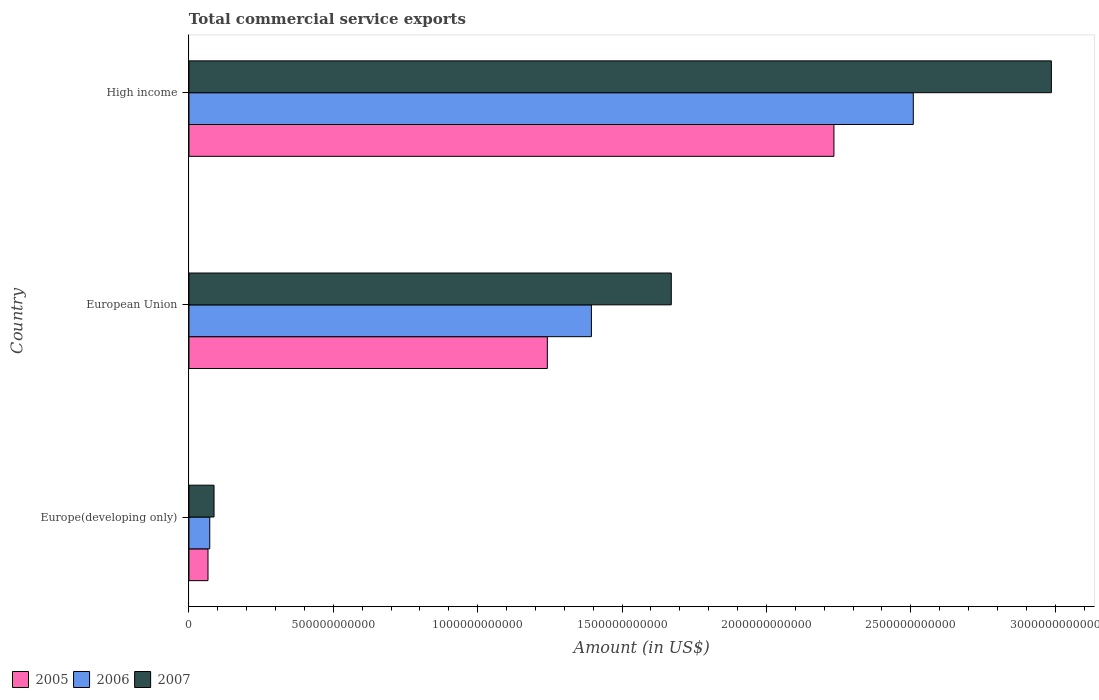How many groups of bars are there?
Provide a succinct answer. 3. Are the number of bars on each tick of the Y-axis equal?
Make the answer very short. Yes. What is the label of the 3rd group of bars from the top?
Your answer should be compact. Europe(developing only). What is the total commercial service exports in 2005 in High income?
Give a very brief answer. 2.23e+12. Across all countries, what is the maximum total commercial service exports in 2006?
Provide a short and direct response. 2.51e+12. Across all countries, what is the minimum total commercial service exports in 2007?
Offer a very short reply. 8.67e+1. In which country was the total commercial service exports in 2007 minimum?
Make the answer very short. Europe(developing only). What is the total total commercial service exports in 2005 in the graph?
Provide a short and direct response. 3.54e+12. What is the difference between the total commercial service exports in 2007 in Europe(developing only) and that in European Union?
Give a very brief answer. -1.58e+12. What is the difference between the total commercial service exports in 2005 in Europe(developing only) and the total commercial service exports in 2007 in High income?
Your response must be concise. -2.92e+12. What is the average total commercial service exports in 2007 per country?
Provide a succinct answer. 1.58e+12. What is the difference between the total commercial service exports in 2007 and total commercial service exports in 2006 in Europe(developing only)?
Keep it short and to the point. 1.48e+1. In how many countries, is the total commercial service exports in 2006 greater than 2000000000000 US$?
Ensure brevity in your answer.  1. What is the ratio of the total commercial service exports in 2006 in European Union to that in High income?
Provide a succinct answer. 0.56. What is the difference between the highest and the second highest total commercial service exports in 2006?
Your response must be concise. 1.11e+12. What is the difference between the highest and the lowest total commercial service exports in 2005?
Your response must be concise. 2.17e+12. In how many countries, is the total commercial service exports in 2005 greater than the average total commercial service exports in 2005 taken over all countries?
Your answer should be compact. 2. Is the sum of the total commercial service exports in 2005 in Europe(developing only) and European Union greater than the maximum total commercial service exports in 2007 across all countries?
Provide a short and direct response. No. What does the 3rd bar from the bottom in European Union represents?
Keep it short and to the point. 2007. Is it the case that in every country, the sum of the total commercial service exports in 2007 and total commercial service exports in 2005 is greater than the total commercial service exports in 2006?
Ensure brevity in your answer.  Yes. Are all the bars in the graph horizontal?
Provide a short and direct response. Yes. How many countries are there in the graph?
Make the answer very short. 3. What is the difference between two consecutive major ticks on the X-axis?
Your response must be concise. 5.00e+11. Are the values on the major ticks of X-axis written in scientific E-notation?
Your answer should be very brief. No. Does the graph contain grids?
Give a very brief answer. No. Where does the legend appear in the graph?
Your answer should be very brief. Bottom left. How many legend labels are there?
Ensure brevity in your answer.  3. What is the title of the graph?
Offer a very short reply. Total commercial service exports. What is the label or title of the X-axis?
Provide a short and direct response. Amount (in US$). What is the Amount (in US$) in 2005 in Europe(developing only)?
Your response must be concise. 6.59e+1. What is the Amount (in US$) in 2006 in Europe(developing only)?
Provide a short and direct response. 7.19e+1. What is the Amount (in US$) of 2007 in Europe(developing only)?
Offer a very short reply. 8.67e+1. What is the Amount (in US$) in 2005 in European Union?
Ensure brevity in your answer.  1.24e+12. What is the Amount (in US$) of 2006 in European Union?
Provide a succinct answer. 1.39e+12. What is the Amount (in US$) in 2007 in European Union?
Keep it short and to the point. 1.67e+12. What is the Amount (in US$) in 2005 in High income?
Ensure brevity in your answer.  2.23e+12. What is the Amount (in US$) in 2006 in High income?
Give a very brief answer. 2.51e+12. What is the Amount (in US$) in 2007 in High income?
Ensure brevity in your answer.  2.99e+12. Across all countries, what is the maximum Amount (in US$) in 2005?
Ensure brevity in your answer.  2.23e+12. Across all countries, what is the maximum Amount (in US$) of 2006?
Make the answer very short. 2.51e+12. Across all countries, what is the maximum Amount (in US$) in 2007?
Give a very brief answer. 2.99e+12. Across all countries, what is the minimum Amount (in US$) of 2005?
Provide a succinct answer. 6.59e+1. Across all countries, what is the minimum Amount (in US$) in 2006?
Provide a succinct answer. 7.19e+1. Across all countries, what is the minimum Amount (in US$) of 2007?
Provide a succinct answer. 8.67e+1. What is the total Amount (in US$) in 2005 in the graph?
Offer a very short reply. 3.54e+12. What is the total Amount (in US$) in 2006 in the graph?
Ensure brevity in your answer.  3.97e+12. What is the total Amount (in US$) of 2007 in the graph?
Your response must be concise. 4.74e+12. What is the difference between the Amount (in US$) in 2005 in Europe(developing only) and that in European Union?
Offer a very short reply. -1.18e+12. What is the difference between the Amount (in US$) in 2006 in Europe(developing only) and that in European Union?
Offer a terse response. -1.32e+12. What is the difference between the Amount (in US$) of 2007 in Europe(developing only) and that in European Union?
Give a very brief answer. -1.58e+12. What is the difference between the Amount (in US$) of 2005 in Europe(developing only) and that in High income?
Give a very brief answer. -2.17e+12. What is the difference between the Amount (in US$) of 2006 in Europe(developing only) and that in High income?
Give a very brief answer. -2.44e+12. What is the difference between the Amount (in US$) of 2007 in Europe(developing only) and that in High income?
Offer a terse response. -2.90e+12. What is the difference between the Amount (in US$) in 2005 in European Union and that in High income?
Make the answer very short. -9.93e+11. What is the difference between the Amount (in US$) of 2006 in European Union and that in High income?
Your answer should be very brief. -1.11e+12. What is the difference between the Amount (in US$) in 2007 in European Union and that in High income?
Provide a succinct answer. -1.32e+12. What is the difference between the Amount (in US$) of 2005 in Europe(developing only) and the Amount (in US$) of 2006 in European Union?
Your answer should be compact. -1.33e+12. What is the difference between the Amount (in US$) of 2005 in Europe(developing only) and the Amount (in US$) of 2007 in European Union?
Offer a terse response. -1.60e+12. What is the difference between the Amount (in US$) in 2006 in Europe(developing only) and the Amount (in US$) in 2007 in European Union?
Your answer should be compact. -1.60e+12. What is the difference between the Amount (in US$) in 2005 in Europe(developing only) and the Amount (in US$) in 2006 in High income?
Make the answer very short. -2.44e+12. What is the difference between the Amount (in US$) in 2005 in Europe(developing only) and the Amount (in US$) in 2007 in High income?
Offer a terse response. -2.92e+12. What is the difference between the Amount (in US$) in 2006 in Europe(developing only) and the Amount (in US$) in 2007 in High income?
Your answer should be very brief. -2.91e+12. What is the difference between the Amount (in US$) in 2005 in European Union and the Amount (in US$) in 2006 in High income?
Give a very brief answer. -1.27e+12. What is the difference between the Amount (in US$) of 2005 in European Union and the Amount (in US$) of 2007 in High income?
Your response must be concise. -1.75e+12. What is the difference between the Amount (in US$) in 2006 in European Union and the Amount (in US$) in 2007 in High income?
Offer a terse response. -1.59e+12. What is the average Amount (in US$) in 2005 per country?
Provide a short and direct response. 1.18e+12. What is the average Amount (in US$) of 2006 per country?
Your answer should be very brief. 1.32e+12. What is the average Amount (in US$) in 2007 per country?
Your answer should be very brief. 1.58e+12. What is the difference between the Amount (in US$) in 2005 and Amount (in US$) in 2006 in Europe(developing only)?
Make the answer very short. -6.08e+09. What is the difference between the Amount (in US$) in 2005 and Amount (in US$) in 2007 in Europe(developing only)?
Offer a terse response. -2.09e+1. What is the difference between the Amount (in US$) of 2006 and Amount (in US$) of 2007 in Europe(developing only)?
Provide a short and direct response. -1.48e+1. What is the difference between the Amount (in US$) of 2005 and Amount (in US$) of 2006 in European Union?
Your answer should be very brief. -1.53e+11. What is the difference between the Amount (in US$) of 2005 and Amount (in US$) of 2007 in European Union?
Provide a short and direct response. -4.29e+11. What is the difference between the Amount (in US$) in 2006 and Amount (in US$) in 2007 in European Union?
Offer a very short reply. -2.77e+11. What is the difference between the Amount (in US$) in 2005 and Amount (in US$) in 2006 in High income?
Provide a short and direct response. -2.75e+11. What is the difference between the Amount (in US$) of 2005 and Amount (in US$) of 2007 in High income?
Ensure brevity in your answer.  -7.53e+11. What is the difference between the Amount (in US$) in 2006 and Amount (in US$) in 2007 in High income?
Give a very brief answer. -4.78e+11. What is the ratio of the Amount (in US$) in 2005 in Europe(developing only) to that in European Union?
Offer a terse response. 0.05. What is the ratio of the Amount (in US$) of 2006 in Europe(developing only) to that in European Union?
Your answer should be compact. 0.05. What is the ratio of the Amount (in US$) of 2007 in Europe(developing only) to that in European Union?
Provide a succinct answer. 0.05. What is the ratio of the Amount (in US$) in 2005 in Europe(developing only) to that in High income?
Your answer should be very brief. 0.03. What is the ratio of the Amount (in US$) of 2006 in Europe(developing only) to that in High income?
Offer a terse response. 0.03. What is the ratio of the Amount (in US$) in 2007 in Europe(developing only) to that in High income?
Ensure brevity in your answer.  0.03. What is the ratio of the Amount (in US$) of 2005 in European Union to that in High income?
Make the answer very short. 0.56. What is the ratio of the Amount (in US$) in 2006 in European Union to that in High income?
Provide a succinct answer. 0.56. What is the ratio of the Amount (in US$) in 2007 in European Union to that in High income?
Your response must be concise. 0.56. What is the difference between the highest and the second highest Amount (in US$) of 2005?
Give a very brief answer. 9.93e+11. What is the difference between the highest and the second highest Amount (in US$) in 2006?
Your response must be concise. 1.11e+12. What is the difference between the highest and the second highest Amount (in US$) in 2007?
Keep it short and to the point. 1.32e+12. What is the difference between the highest and the lowest Amount (in US$) in 2005?
Keep it short and to the point. 2.17e+12. What is the difference between the highest and the lowest Amount (in US$) of 2006?
Make the answer very short. 2.44e+12. What is the difference between the highest and the lowest Amount (in US$) of 2007?
Give a very brief answer. 2.90e+12. 